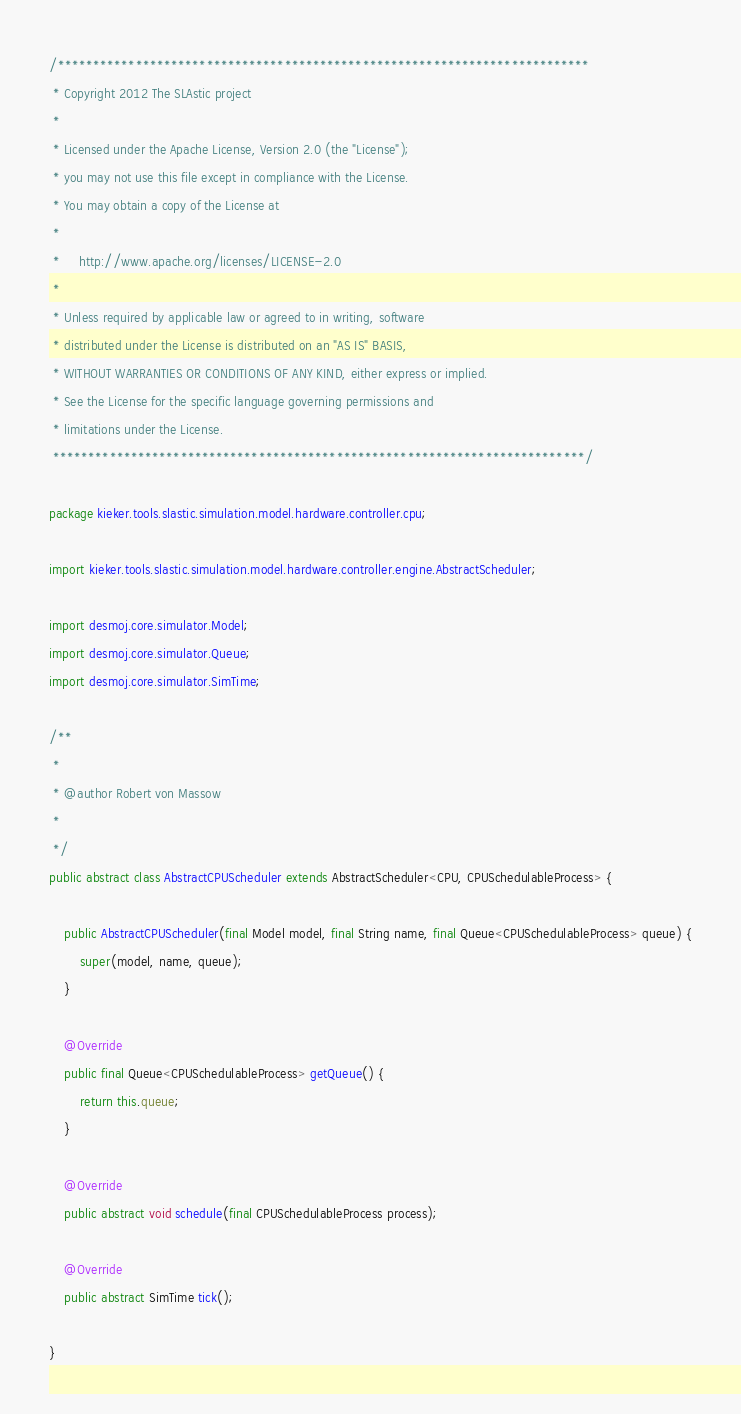<code> <loc_0><loc_0><loc_500><loc_500><_Java_>/***************************************************************************
 * Copyright 2012 The SLAstic project
 *
 * Licensed under the Apache License, Version 2.0 (the "License");
 * you may not use this file except in compliance with the License.
 * You may obtain a copy of the License at
 *
 *     http://www.apache.org/licenses/LICENSE-2.0
 *
 * Unless required by applicable law or agreed to in writing, software
 * distributed under the License is distributed on an "AS IS" BASIS,
 * WITHOUT WARRANTIES OR CONDITIONS OF ANY KIND, either express or implied.
 * See the License for the specific language governing permissions and
 * limitations under the License.
 ***************************************************************************/

package kieker.tools.slastic.simulation.model.hardware.controller.cpu;

import kieker.tools.slastic.simulation.model.hardware.controller.engine.AbstractScheduler;

import desmoj.core.simulator.Model;
import desmoj.core.simulator.Queue;
import desmoj.core.simulator.SimTime;

/**
 * 
 * @author Robert von Massow
 * 
 */
public abstract class AbstractCPUScheduler extends AbstractScheduler<CPU, CPUSchedulableProcess> {

	public AbstractCPUScheduler(final Model model, final String name, final Queue<CPUSchedulableProcess> queue) {
		super(model, name, queue);
	}

	@Override
	public final Queue<CPUSchedulableProcess> getQueue() {
		return this.queue;
	}

	@Override
	public abstract void schedule(final CPUSchedulableProcess process);

	@Override
	public abstract SimTime tick();

}
</code> 